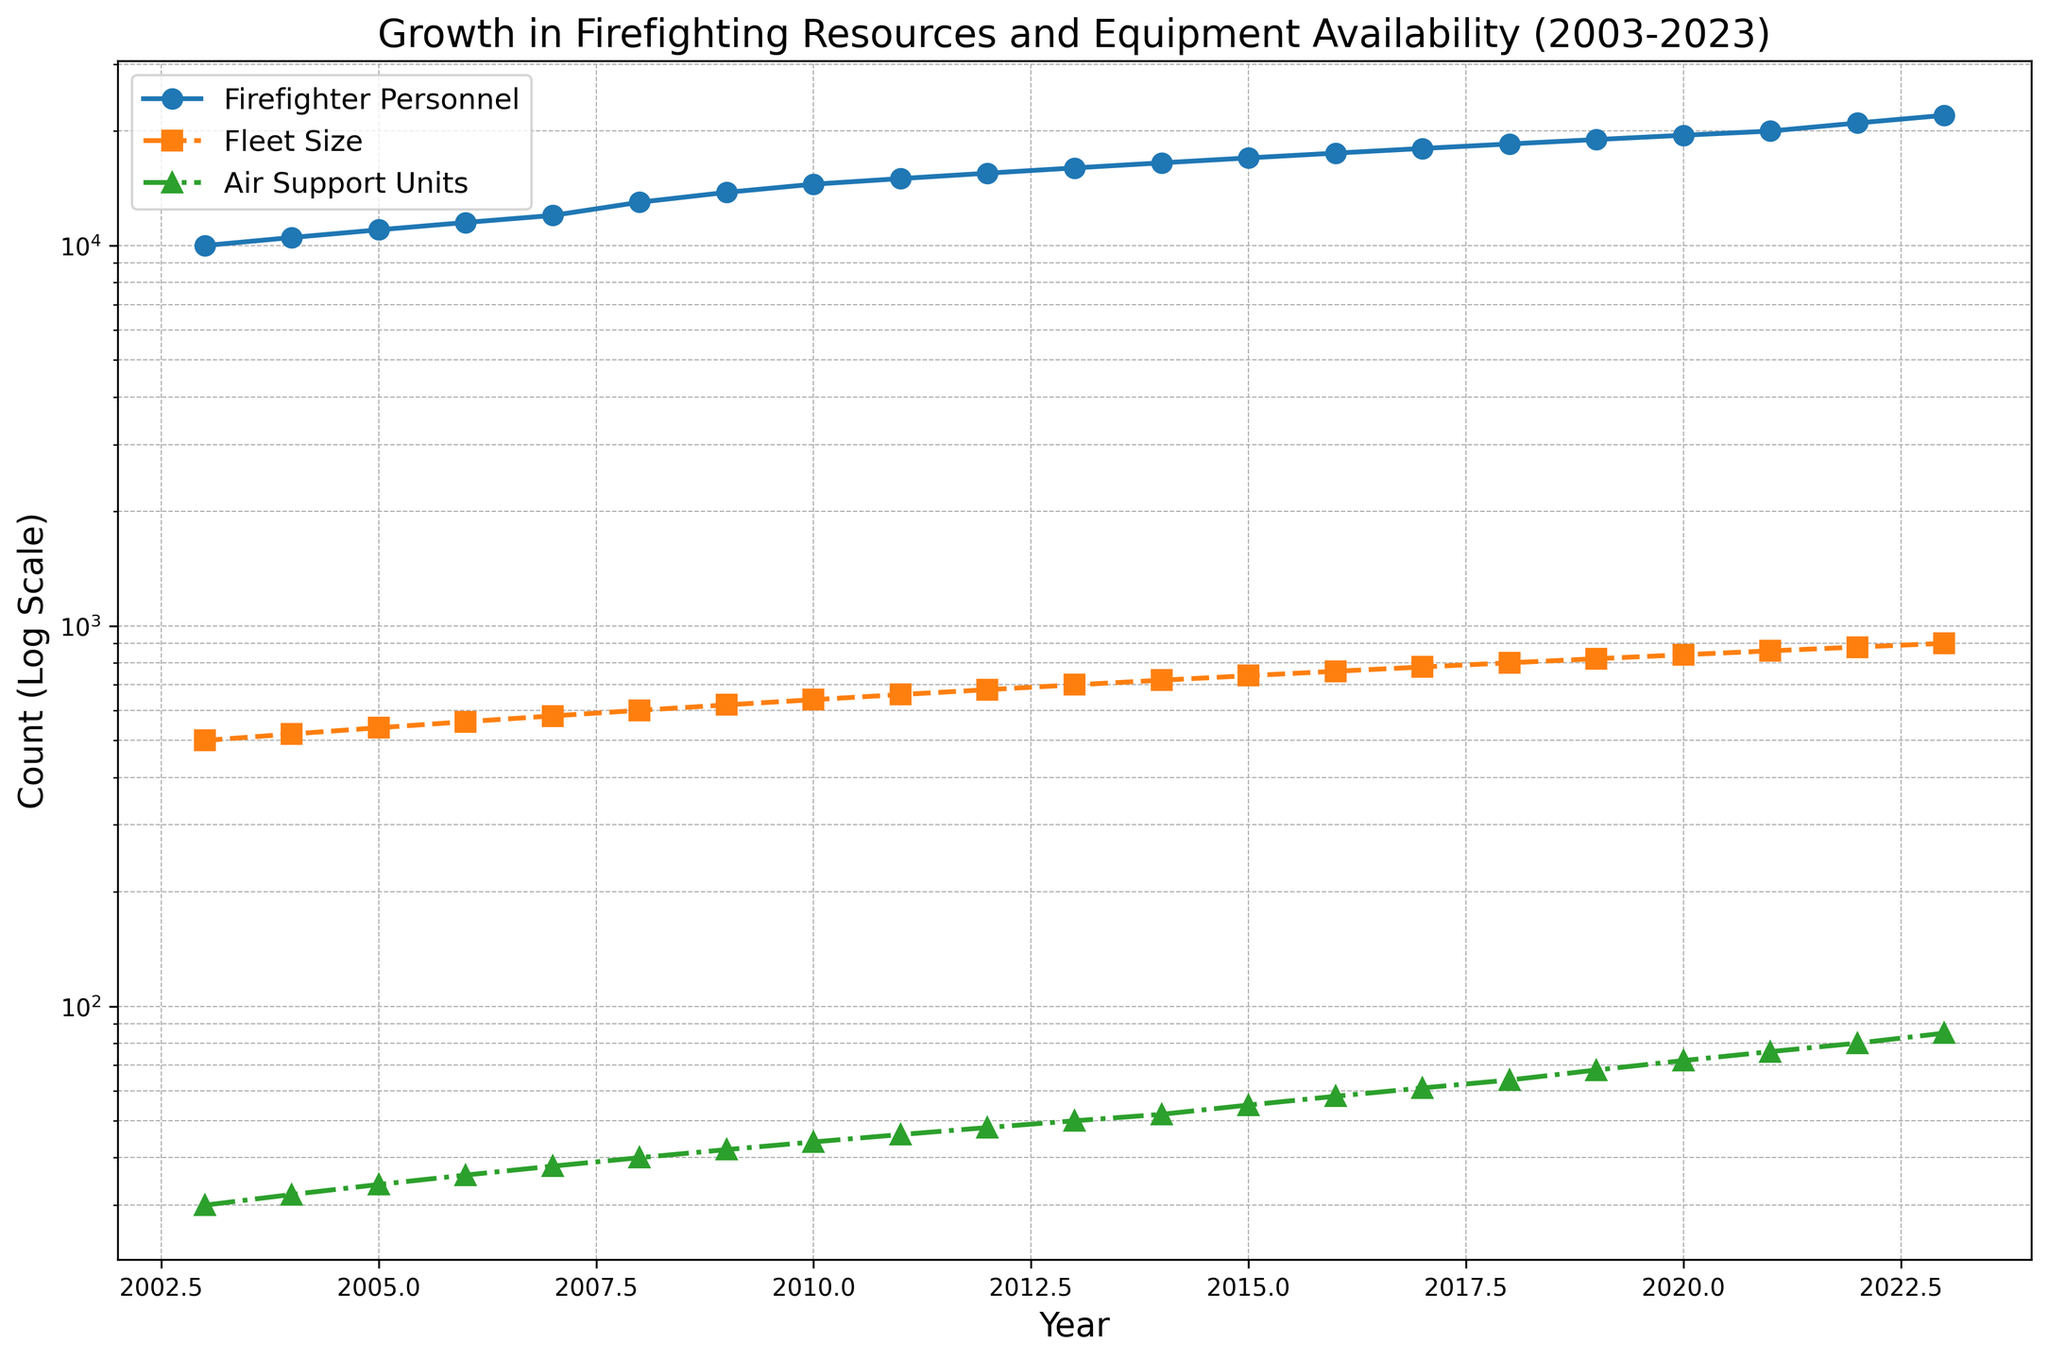How has the availability of air support units grown from 2003 to 2023? To find the growth, we take the air support units in 2023 and subtract the units available in 2003. The units available in 2023 are 85, and in 2003, they were 30. The growth is 85 - 30 = 55 units.
Answer: 55 units Which resource has seen the largest increase in count from 2003 to 2023? To determine the largest increase, we calculate the increase for each resource: 
- Firefighter Personnel: 22000 - 10000 = 12000
- Fleet Size: 900 - 500 = 400
- Air Support Units: 85 - 30 = 55
The largest increase is in Firefighter Personnel with a growth of 12000.
Answer: Firefighter Personnel In which year did the fleet size surpass 700 for the first time? By examining the plot, we look for the first year the Fleet Size line crosses the 700 mark. This occurs in the year 2013 when the fleet size reaches 700.
Answer: 2013 What is the annual average growth rate of firefighter personnel over the two decades? To find the annual average growth rate, we use the formula [(Final Value/Initial Value)^(1/number of periods) - 1]. 
Final Value = 22000, Initial Value = 10000, Number of periods = 20 years.
[(22000/10000)^(1/20) - 1] = [2.2^(1/20) - 1] ≈ [1.0386 - 1] ≈ 0.0386 or 3.86%.
Answer: 3.86% Compare the trend of fleet size and air support units from 2003 to 2023. Which one has a steeper growth? By observing both the Fleet Size and Air Support Units on the logscale plot, both lines grow steadily, but visually, the Air Support Units' growth appears to be steeper compared to the Fleet Size. This is because Air Support Units increased from 30 to 85 (almost tripling), while Fleet Size grew from 500 to 900 (less than doubling).
Answer: Air Support Units Which year shows equal growth in both fleet size and firefighter personnel compared to the previous year? We need to identify a year where both resources grew by an equal absolute amount. Each year from 2003 to 2023 shows consistent incremental growth, but the plot's granularity may make it difficult to pinpoint equal growth values exactly. Numerically, no specific year shows equal growth as the increments differ slightly for each resource.
Answer: No specific year How many years did it take for firefighter personnel to grow from 10,000 to 15,000? From the data and the visual representation, firefighter personnel started at 10,000 in 2003 and reached 15,000 in 2011. Hence, it took 2011 - 2003 = 8 years.
Answer: 8 years In what year did air support units first reach or exceed 50 units? By looking at the plotted trends, the air support units first reach 50 units in the year 2013.
Answer: 2013 By what factor did the fleet size grow between 2003 and 2023? To find the growth factor, we divide the final value by the initial value. Fleet size in 2023 is 900, and in 2003 it was 500. The growth factor is 900 / 500 = 1.8.
Answer: 1.8 What visual pattern do you notice about the relative growth of firefighter personnel compared to fleet size over the two decades? Visual observation of the plot indicates that the line representing firefighter personnel consistently trends above the fleet size line, showing that the number of personnel has always been larger. However, both exhibit steady growth throughout the period, indicated by their upward slopes.
Answer: Firefighter personnel consistently above fleet size, both grow steadily 